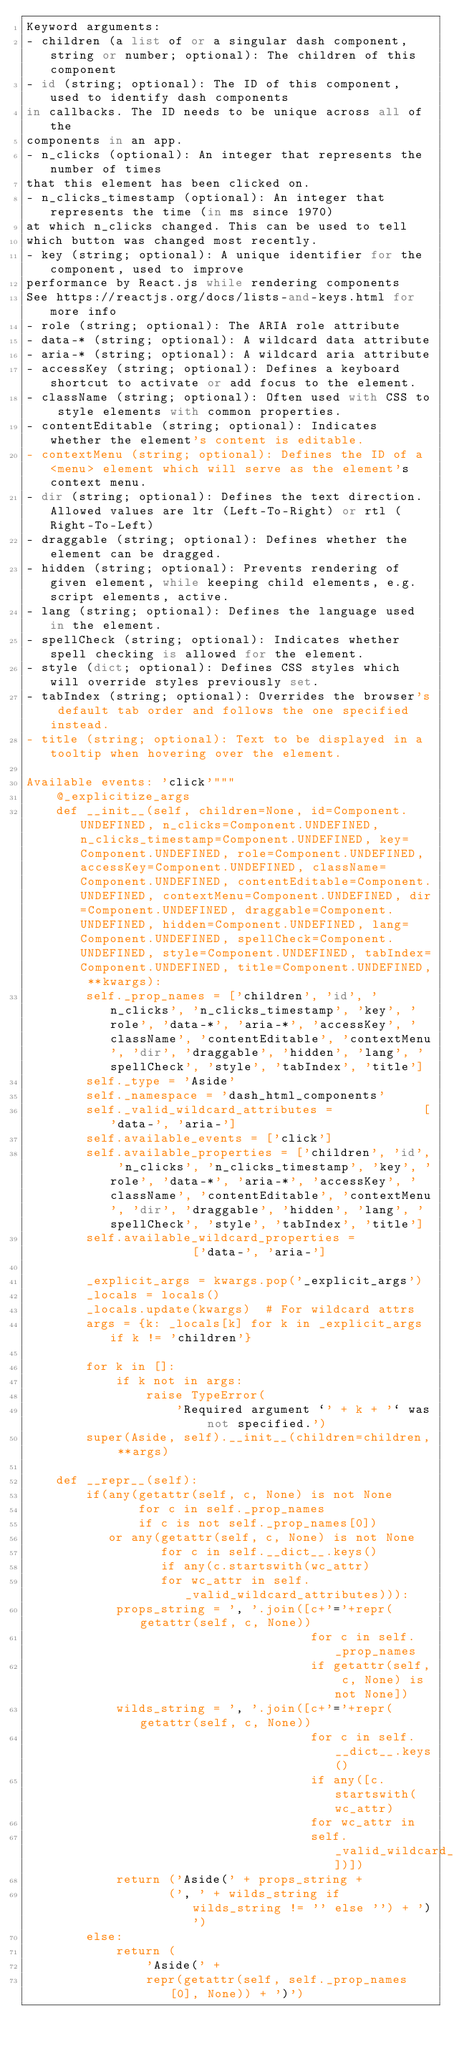<code> <loc_0><loc_0><loc_500><loc_500><_Python_>Keyword arguments:
- children (a list of or a singular dash component, string or number; optional): The children of this component
- id (string; optional): The ID of this component, used to identify dash components
in callbacks. The ID needs to be unique across all of the
components in an app.
- n_clicks (optional): An integer that represents the number of times
that this element has been clicked on.
- n_clicks_timestamp (optional): An integer that represents the time (in ms since 1970)
at which n_clicks changed. This can be used to tell
which button was changed most recently.
- key (string; optional): A unique identifier for the component, used to improve
performance by React.js while rendering components
See https://reactjs.org/docs/lists-and-keys.html for more info
- role (string; optional): The ARIA role attribute
- data-* (string; optional): A wildcard data attribute
- aria-* (string; optional): A wildcard aria attribute
- accessKey (string; optional): Defines a keyboard shortcut to activate or add focus to the element.
- className (string; optional): Often used with CSS to style elements with common properties.
- contentEditable (string; optional): Indicates whether the element's content is editable.
- contextMenu (string; optional): Defines the ID of a <menu> element which will serve as the element's context menu.
- dir (string; optional): Defines the text direction. Allowed values are ltr (Left-To-Right) or rtl (Right-To-Left)
- draggable (string; optional): Defines whether the element can be dragged.
- hidden (string; optional): Prevents rendering of given element, while keeping child elements, e.g. script elements, active.
- lang (string; optional): Defines the language used in the element.
- spellCheck (string; optional): Indicates whether spell checking is allowed for the element.
- style (dict; optional): Defines CSS styles which will override styles previously set.
- tabIndex (string; optional): Overrides the browser's default tab order and follows the one specified instead.
- title (string; optional): Text to be displayed in a tooltip when hovering over the element.

Available events: 'click'"""
    @_explicitize_args
    def __init__(self, children=None, id=Component.UNDEFINED, n_clicks=Component.UNDEFINED, n_clicks_timestamp=Component.UNDEFINED, key=Component.UNDEFINED, role=Component.UNDEFINED, accessKey=Component.UNDEFINED, className=Component.UNDEFINED, contentEditable=Component.UNDEFINED, contextMenu=Component.UNDEFINED, dir=Component.UNDEFINED, draggable=Component.UNDEFINED, hidden=Component.UNDEFINED, lang=Component.UNDEFINED, spellCheck=Component.UNDEFINED, style=Component.UNDEFINED, tabIndex=Component.UNDEFINED, title=Component.UNDEFINED, **kwargs):
        self._prop_names = ['children', 'id', 'n_clicks', 'n_clicks_timestamp', 'key', 'role', 'data-*', 'aria-*', 'accessKey', 'className', 'contentEditable', 'contextMenu', 'dir', 'draggable', 'hidden', 'lang', 'spellCheck', 'style', 'tabIndex', 'title']
        self._type = 'Aside'
        self._namespace = 'dash_html_components'
        self._valid_wildcard_attributes =            ['data-', 'aria-']
        self.available_events = ['click']
        self.available_properties = ['children', 'id', 'n_clicks', 'n_clicks_timestamp', 'key', 'role', 'data-*', 'aria-*', 'accessKey', 'className', 'contentEditable', 'contextMenu', 'dir', 'draggable', 'hidden', 'lang', 'spellCheck', 'style', 'tabIndex', 'title']
        self.available_wildcard_properties =            ['data-', 'aria-']

        _explicit_args = kwargs.pop('_explicit_args')
        _locals = locals()
        _locals.update(kwargs)  # For wildcard attrs
        args = {k: _locals[k] for k in _explicit_args if k != 'children'}

        for k in []:
            if k not in args:
                raise TypeError(
                    'Required argument `' + k + '` was not specified.')
        super(Aside, self).__init__(children=children, **args)

    def __repr__(self):
        if(any(getattr(self, c, None) is not None
               for c in self._prop_names
               if c is not self._prop_names[0])
           or any(getattr(self, c, None) is not None
                  for c in self.__dict__.keys()
                  if any(c.startswith(wc_attr)
                  for wc_attr in self._valid_wildcard_attributes))):
            props_string = ', '.join([c+'='+repr(getattr(self, c, None))
                                      for c in self._prop_names
                                      if getattr(self, c, None) is not None])
            wilds_string = ', '.join([c+'='+repr(getattr(self, c, None))
                                      for c in self.__dict__.keys()
                                      if any([c.startswith(wc_attr)
                                      for wc_attr in
                                      self._valid_wildcard_attributes])])
            return ('Aside(' + props_string +
                   (', ' + wilds_string if wilds_string != '' else '') + ')')
        else:
            return (
                'Aside(' +
                repr(getattr(self, self._prop_names[0], None)) + ')')
</code> 